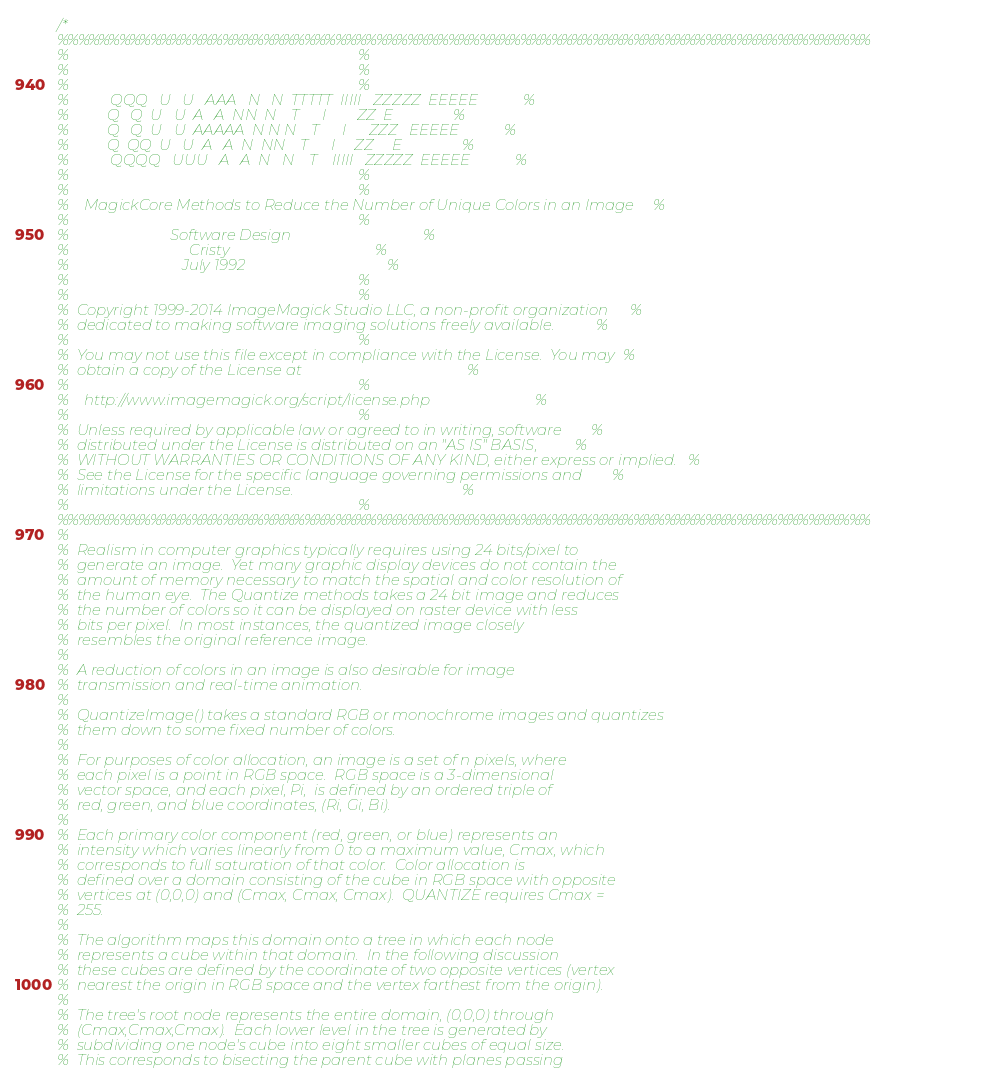Convert code to text. <code><loc_0><loc_0><loc_500><loc_500><_C_>/*
%%%%%%%%%%%%%%%%%%%%%%%%%%%%%%%%%%%%%%%%%%%%%%%%%%%%%%%%%%%%%%%%%%%%%%%%%%%%%%%
%                                                                             %
%                                                                             %
%                                                                             %
%           QQQ   U   U   AAA   N   N  TTTTT  IIIII   ZZZZZ  EEEEE            %
%          Q   Q  U   U  A   A  NN  N    T      I        ZZ  E                %
%          Q   Q  U   U  AAAAA  N N N    T      I      ZZZ   EEEEE            %
%          Q  QQ  U   U  A   A  N  NN    T      I     ZZ     E                %
%           QQQQ   UUU   A   A  N   N    T    IIIII   ZZZZZ  EEEEE            %
%                                                                             %
%                                                                             %
%    MagickCore Methods to Reduce the Number of Unique Colors in an Image     %
%                                                                             %
%                           Software Design                                   %
%                                Cristy                                       %
%                              July 1992                                      %
%                                                                             %
%                                                                             %
%  Copyright 1999-2014 ImageMagick Studio LLC, a non-profit organization      %
%  dedicated to making software imaging solutions freely available.           %
%                                                                             %
%  You may not use this file except in compliance with the License.  You may  %
%  obtain a copy of the License at                                            %
%                                                                             %
%    http://www.imagemagick.org/script/license.php                            %
%                                                                             %
%  Unless required by applicable law or agreed to in writing, software        %
%  distributed under the License is distributed on an "AS IS" BASIS,          %
%  WITHOUT WARRANTIES OR CONDITIONS OF ANY KIND, either express or implied.   %
%  See the License for the specific language governing permissions and        %
%  limitations under the License.                                             %
%                                                                             %
%%%%%%%%%%%%%%%%%%%%%%%%%%%%%%%%%%%%%%%%%%%%%%%%%%%%%%%%%%%%%%%%%%%%%%%%%%%%%%%
%
%  Realism in computer graphics typically requires using 24 bits/pixel to
%  generate an image.  Yet many graphic display devices do not contain the
%  amount of memory necessary to match the spatial and color resolution of
%  the human eye.  The Quantize methods takes a 24 bit image and reduces
%  the number of colors so it can be displayed on raster device with less
%  bits per pixel.  In most instances, the quantized image closely
%  resembles the original reference image.
%
%  A reduction of colors in an image is also desirable for image
%  transmission and real-time animation.
%
%  QuantizeImage() takes a standard RGB or monochrome images and quantizes
%  them down to some fixed number of colors.
%
%  For purposes of color allocation, an image is a set of n pixels, where
%  each pixel is a point in RGB space.  RGB space is a 3-dimensional
%  vector space, and each pixel, Pi,  is defined by an ordered triple of
%  red, green, and blue coordinates, (Ri, Gi, Bi).
%
%  Each primary color component (red, green, or blue) represents an
%  intensity which varies linearly from 0 to a maximum value, Cmax, which
%  corresponds to full saturation of that color.  Color allocation is
%  defined over a domain consisting of the cube in RGB space with opposite
%  vertices at (0,0,0) and (Cmax, Cmax, Cmax).  QUANTIZE requires Cmax =
%  255.
%
%  The algorithm maps this domain onto a tree in which each node
%  represents a cube within that domain.  In the following discussion
%  these cubes are defined by the coordinate of two opposite vertices (vertex
%  nearest the origin in RGB space and the vertex farthest from the origin).
%
%  The tree's root node represents the entire domain, (0,0,0) through
%  (Cmax,Cmax,Cmax).  Each lower level in the tree is generated by
%  subdividing one node's cube into eight smaller cubes of equal size.
%  This corresponds to bisecting the parent cube with planes passing</code> 